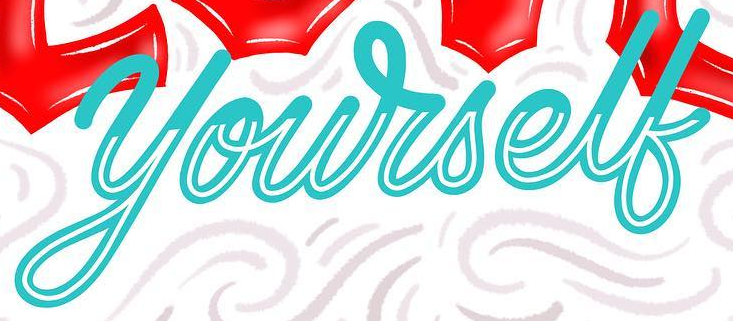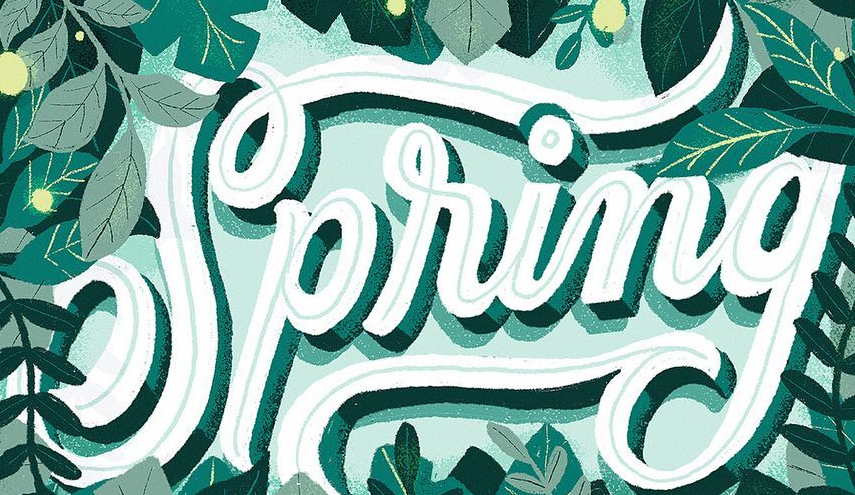What words can you see in these images in sequence, separated by a semicolon? yourself; Spring 